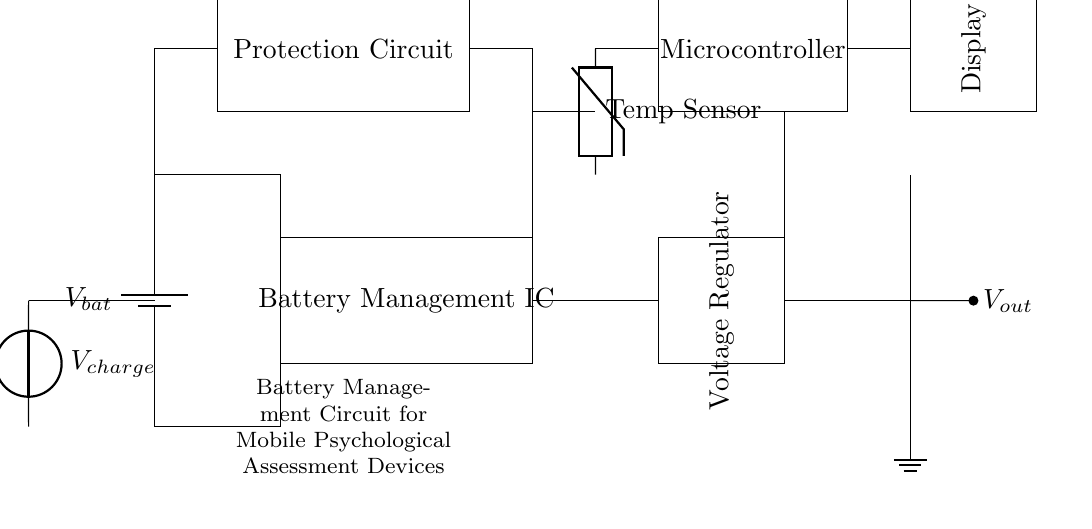What type of circuit is depicted? The circuit is a battery management circuit specifically designed for a mobile device. It manages battery charging and discharging, ensuring efficient use of energy.
Answer: Battery management circuit What is the role of the battery management IC? The battery management IC controls the charging and discharging of the battery, ensuring proper voltage levels and safe operation. It also provides important functions like overcharge protection.
Answer: Control battery operation What is the primary function of the voltage regulator? The voltage regulator maintains a constant output voltage regardless of variations in input voltage from the battery, ensuring stable power supply to the device.
Answer: Maintain output voltage How is the temperature sensor used in this circuit? The temperature sensor monitors the battery temperature, providing feedback to the battery management IC to prevent overheating and potential hazards.
Answer: Monitor battery temperature What is the significance of the protection circuit? The protection circuit safeguards the battery from conditions like overcharging, short circuits, and excessive discharging, prolonging battery life and ensuring safe operation.
Answer: Safeguard the battery Which component provides the charging input? The voltage source labeled as V_charge allows external power to charge the battery when connected, restoring energy for the device's use.
Answer: Voltage source V_charge What is the purpose of the display in this mobile device? The display provides visual feedback to the user, showing important information about battery status, device performance, or psychological assessment results.
Answer: User feedback information 